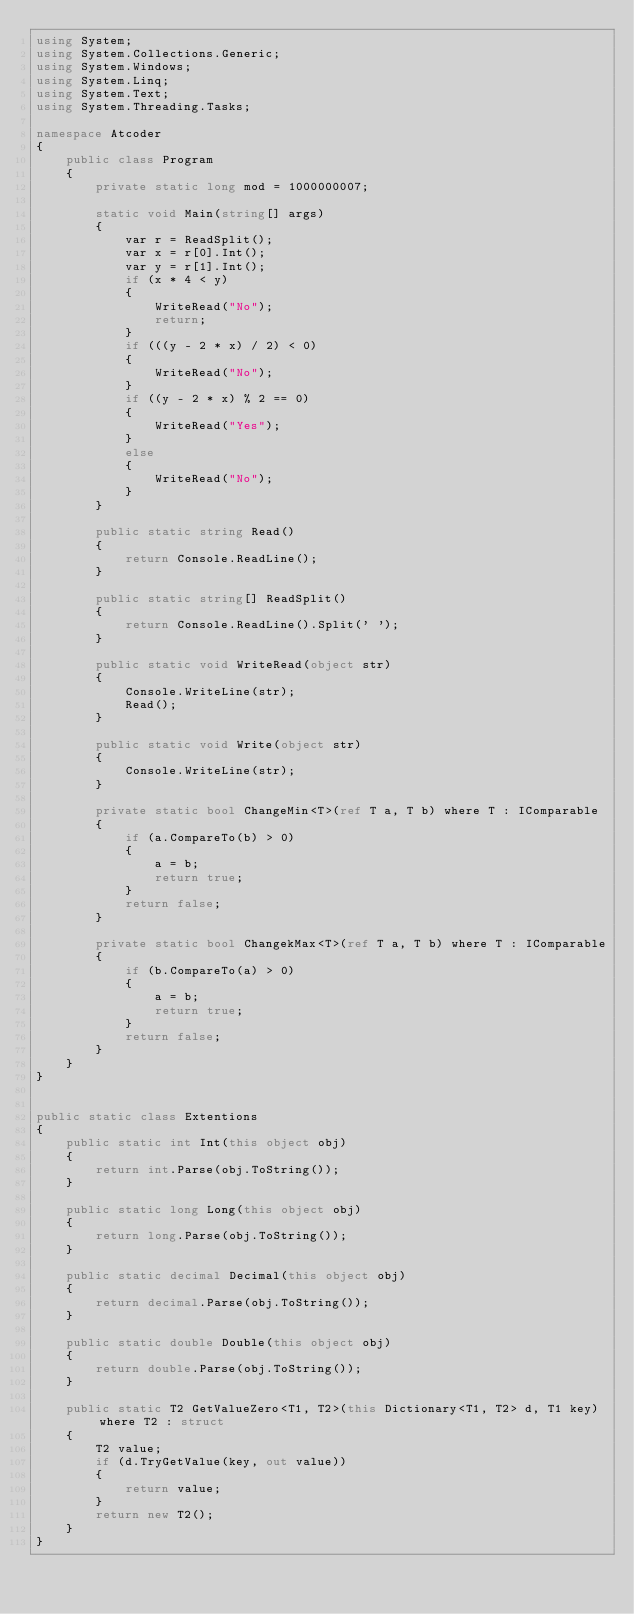Convert code to text. <code><loc_0><loc_0><loc_500><loc_500><_C#_>using System;
using System.Collections.Generic;
using System.Windows;
using System.Linq;
using System.Text;
using System.Threading.Tasks;

namespace Atcoder
{
    public class Program
    {
        private static long mod = 1000000007;

        static void Main(string[] args)
        {
            var r = ReadSplit();
            var x = r[0].Int();
            var y = r[1].Int();
            if (x * 4 < y)
            {
                WriteRead("No");
                return;
            }
            if (((y - 2 * x) / 2) < 0)
            {
                WriteRead("No");
            }
            if ((y - 2 * x) % 2 == 0)
            {
                WriteRead("Yes");
            }
            else
            {
                WriteRead("No");
            }
        }

        public static string Read()
        {
            return Console.ReadLine();
        }

        public static string[] ReadSplit()
        {
            return Console.ReadLine().Split(' ');
        }

        public static void WriteRead(object str)
        {
            Console.WriteLine(str);
            Read();
        }

        public static void Write(object str)
        {
            Console.WriteLine(str);
        }

        private static bool ChangeMin<T>(ref T a, T b) where T : IComparable
        {
            if (a.CompareTo(b) > 0)
            {
                a = b;
                return true;
            }
            return false;
        }

        private static bool ChangekMax<T>(ref T a, T b) where T : IComparable
        {
            if (b.CompareTo(a) > 0)
            {
                a = b;
                return true;
            }
            return false;
        }
    }
}


public static class Extentions
{
    public static int Int(this object obj)
    {
        return int.Parse(obj.ToString());
    }

    public static long Long(this object obj)
    {
        return long.Parse(obj.ToString());
    }

    public static decimal Decimal(this object obj)
    {
        return decimal.Parse(obj.ToString());
    }

    public static double Double(this object obj)
    {
        return double.Parse(obj.ToString());
    }

    public static T2 GetValueZero<T1, T2>(this Dictionary<T1, T2> d, T1 key) where T2 : struct
    {
        T2 value;
        if (d.TryGetValue(key, out value))
        {
            return value;
        }
        return new T2();
    }
}

</code> 